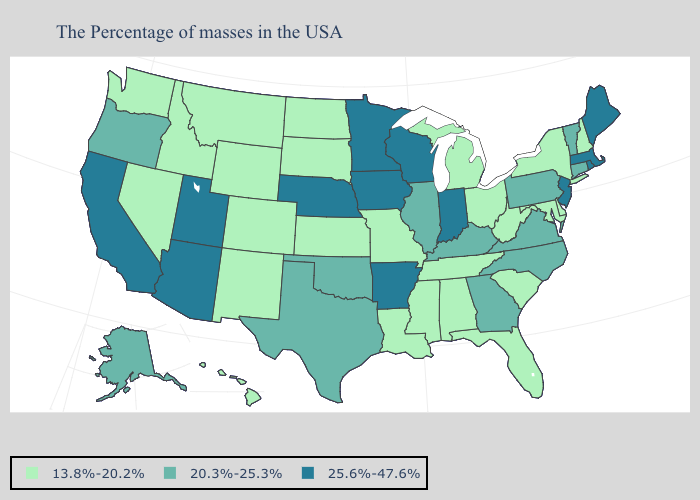How many symbols are there in the legend?
Be succinct. 3. Which states have the highest value in the USA?
Quick response, please. Maine, Massachusetts, Rhode Island, New Jersey, Indiana, Wisconsin, Arkansas, Minnesota, Iowa, Nebraska, Utah, Arizona, California. What is the value of Missouri?
Be succinct. 13.8%-20.2%. What is the lowest value in states that border North Carolina?
Keep it brief. 13.8%-20.2%. Name the states that have a value in the range 25.6%-47.6%?
Concise answer only. Maine, Massachusetts, Rhode Island, New Jersey, Indiana, Wisconsin, Arkansas, Minnesota, Iowa, Nebraska, Utah, Arizona, California. Among the states that border Kentucky , which have the lowest value?
Quick response, please. West Virginia, Ohio, Tennessee, Missouri. What is the highest value in the USA?
Concise answer only. 25.6%-47.6%. Does New Hampshire have the highest value in the Northeast?
Be succinct. No. Is the legend a continuous bar?
Answer briefly. No. What is the highest value in states that border South Carolina?
Short answer required. 20.3%-25.3%. Name the states that have a value in the range 13.8%-20.2%?
Concise answer only. New Hampshire, New York, Delaware, Maryland, South Carolina, West Virginia, Ohio, Florida, Michigan, Alabama, Tennessee, Mississippi, Louisiana, Missouri, Kansas, South Dakota, North Dakota, Wyoming, Colorado, New Mexico, Montana, Idaho, Nevada, Washington, Hawaii. What is the lowest value in the USA?
Concise answer only. 13.8%-20.2%. What is the lowest value in the USA?
Give a very brief answer. 13.8%-20.2%. What is the value of Missouri?
Keep it brief. 13.8%-20.2%. Name the states that have a value in the range 13.8%-20.2%?
Concise answer only. New Hampshire, New York, Delaware, Maryland, South Carolina, West Virginia, Ohio, Florida, Michigan, Alabama, Tennessee, Mississippi, Louisiana, Missouri, Kansas, South Dakota, North Dakota, Wyoming, Colorado, New Mexico, Montana, Idaho, Nevada, Washington, Hawaii. 